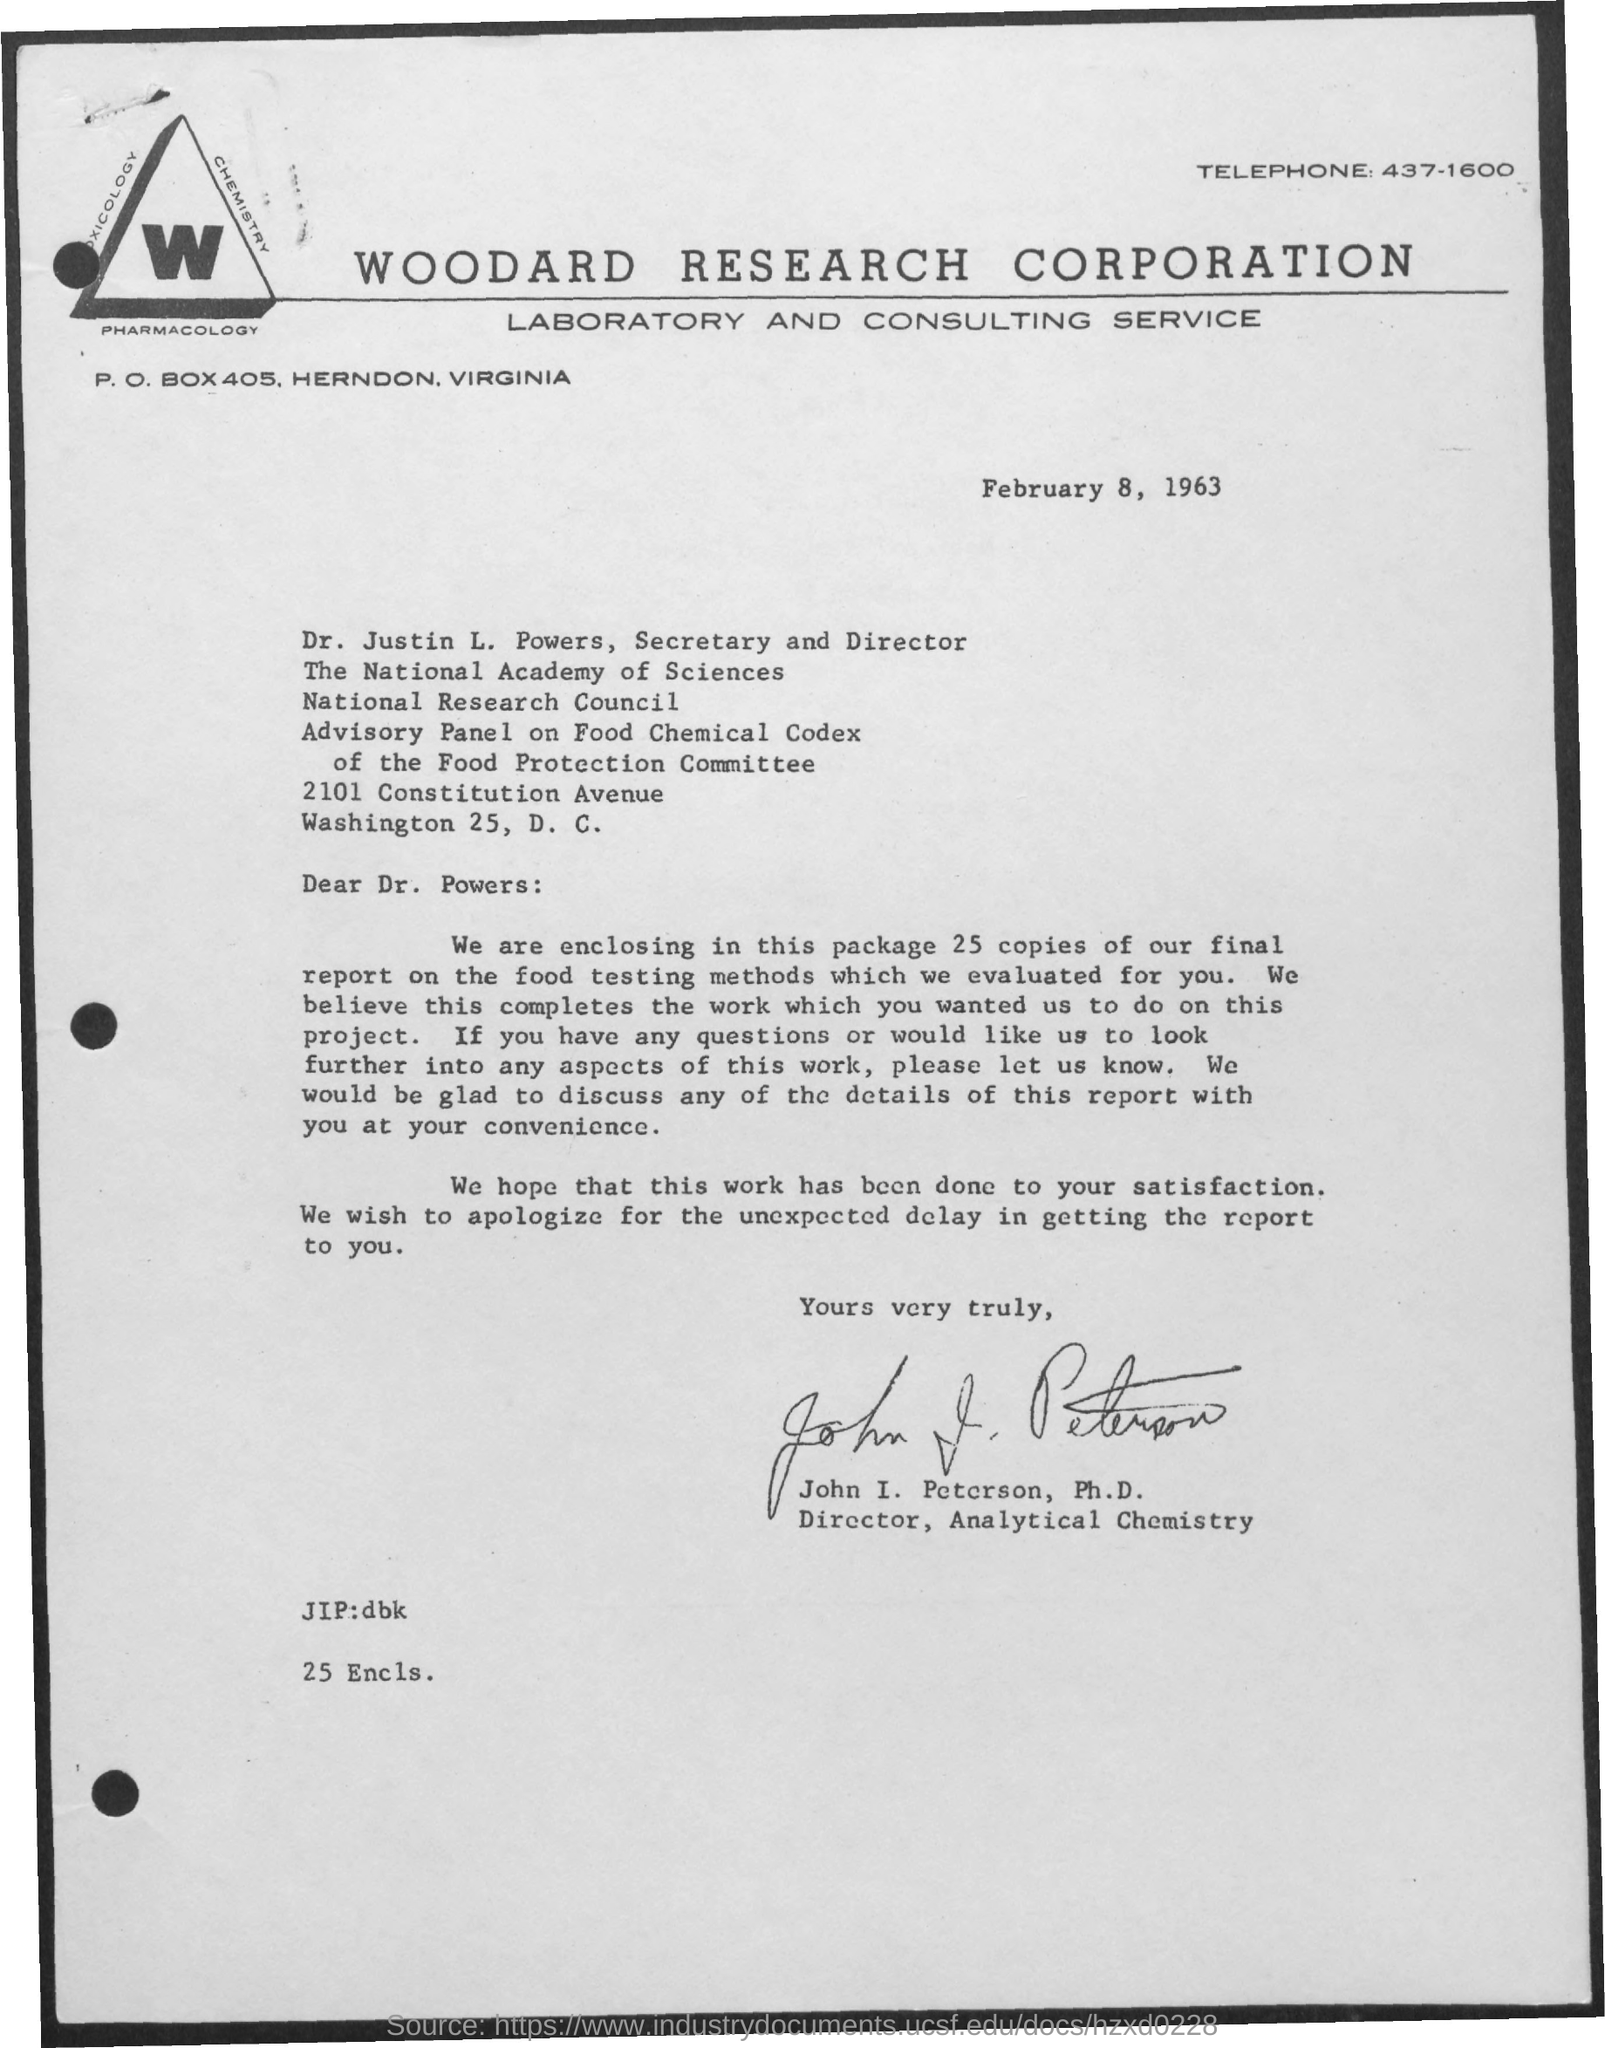What is the telephone number of woodard research corporation laboratory and consulting service?
Your answer should be compact. 437-1600. What is the p.o box no. of woodard research corporation laboratory and consulting service?
Give a very brief answer. 405. Who is the secretary and director of the national academy of sciences?
Ensure brevity in your answer.  Dr. Justin L. Powers. How many copies of final reports are enclosed along with letter?
Offer a very short reply. 25. Who wrote this letter?
Provide a succinct answer. John I. Peterson, Ph.D. 